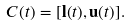<formula> <loc_0><loc_0><loc_500><loc_500>C ( t ) = [ \mathbf l ( t ) , \mathbf u ( t ) ] .</formula> 